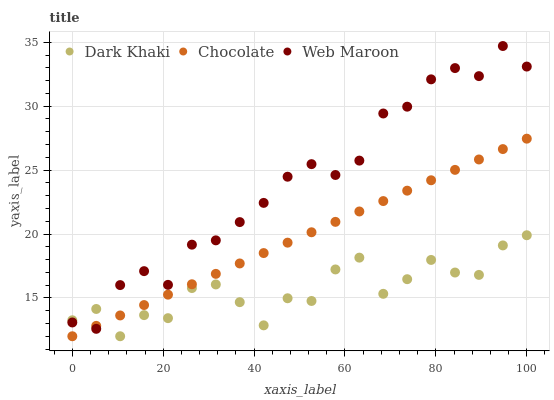Does Dark Khaki have the minimum area under the curve?
Answer yes or no. Yes. Does Web Maroon have the maximum area under the curve?
Answer yes or no. Yes. Does Chocolate have the minimum area under the curve?
Answer yes or no. No. Does Chocolate have the maximum area under the curve?
Answer yes or no. No. Is Chocolate the smoothest?
Answer yes or no. Yes. Is Dark Khaki the roughest?
Answer yes or no. Yes. Is Web Maroon the smoothest?
Answer yes or no. No. Is Web Maroon the roughest?
Answer yes or no. No. Does Dark Khaki have the lowest value?
Answer yes or no. Yes. Does Web Maroon have the lowest value?
Answer yes or no. No. Does Web Maroon have the highest value?
Answer yes or no. Yes. Does Chocolate have the highest value?
Answer yes or no. No. Does Web Maroon intersect Chocolate?
Answer yes or no. Yes. Is Web Maroon less than Chocolate?
Answer yes or no. No. Is Web Maroon greater than Chocolate?
Answer yes or no. No. 